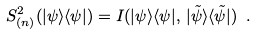Convert formula to latex. <formula><loc_0><loc_0><loc_500><loc_500>S _ { ( n ) } ^ { 2 } ( | \psi \rangle \langle \psi | ) = I ( | \psi \rangle \langle \psi | , \, | \tilde { \psi } \rangle \langle \tilde { \psi } | ) \ .</formula> 